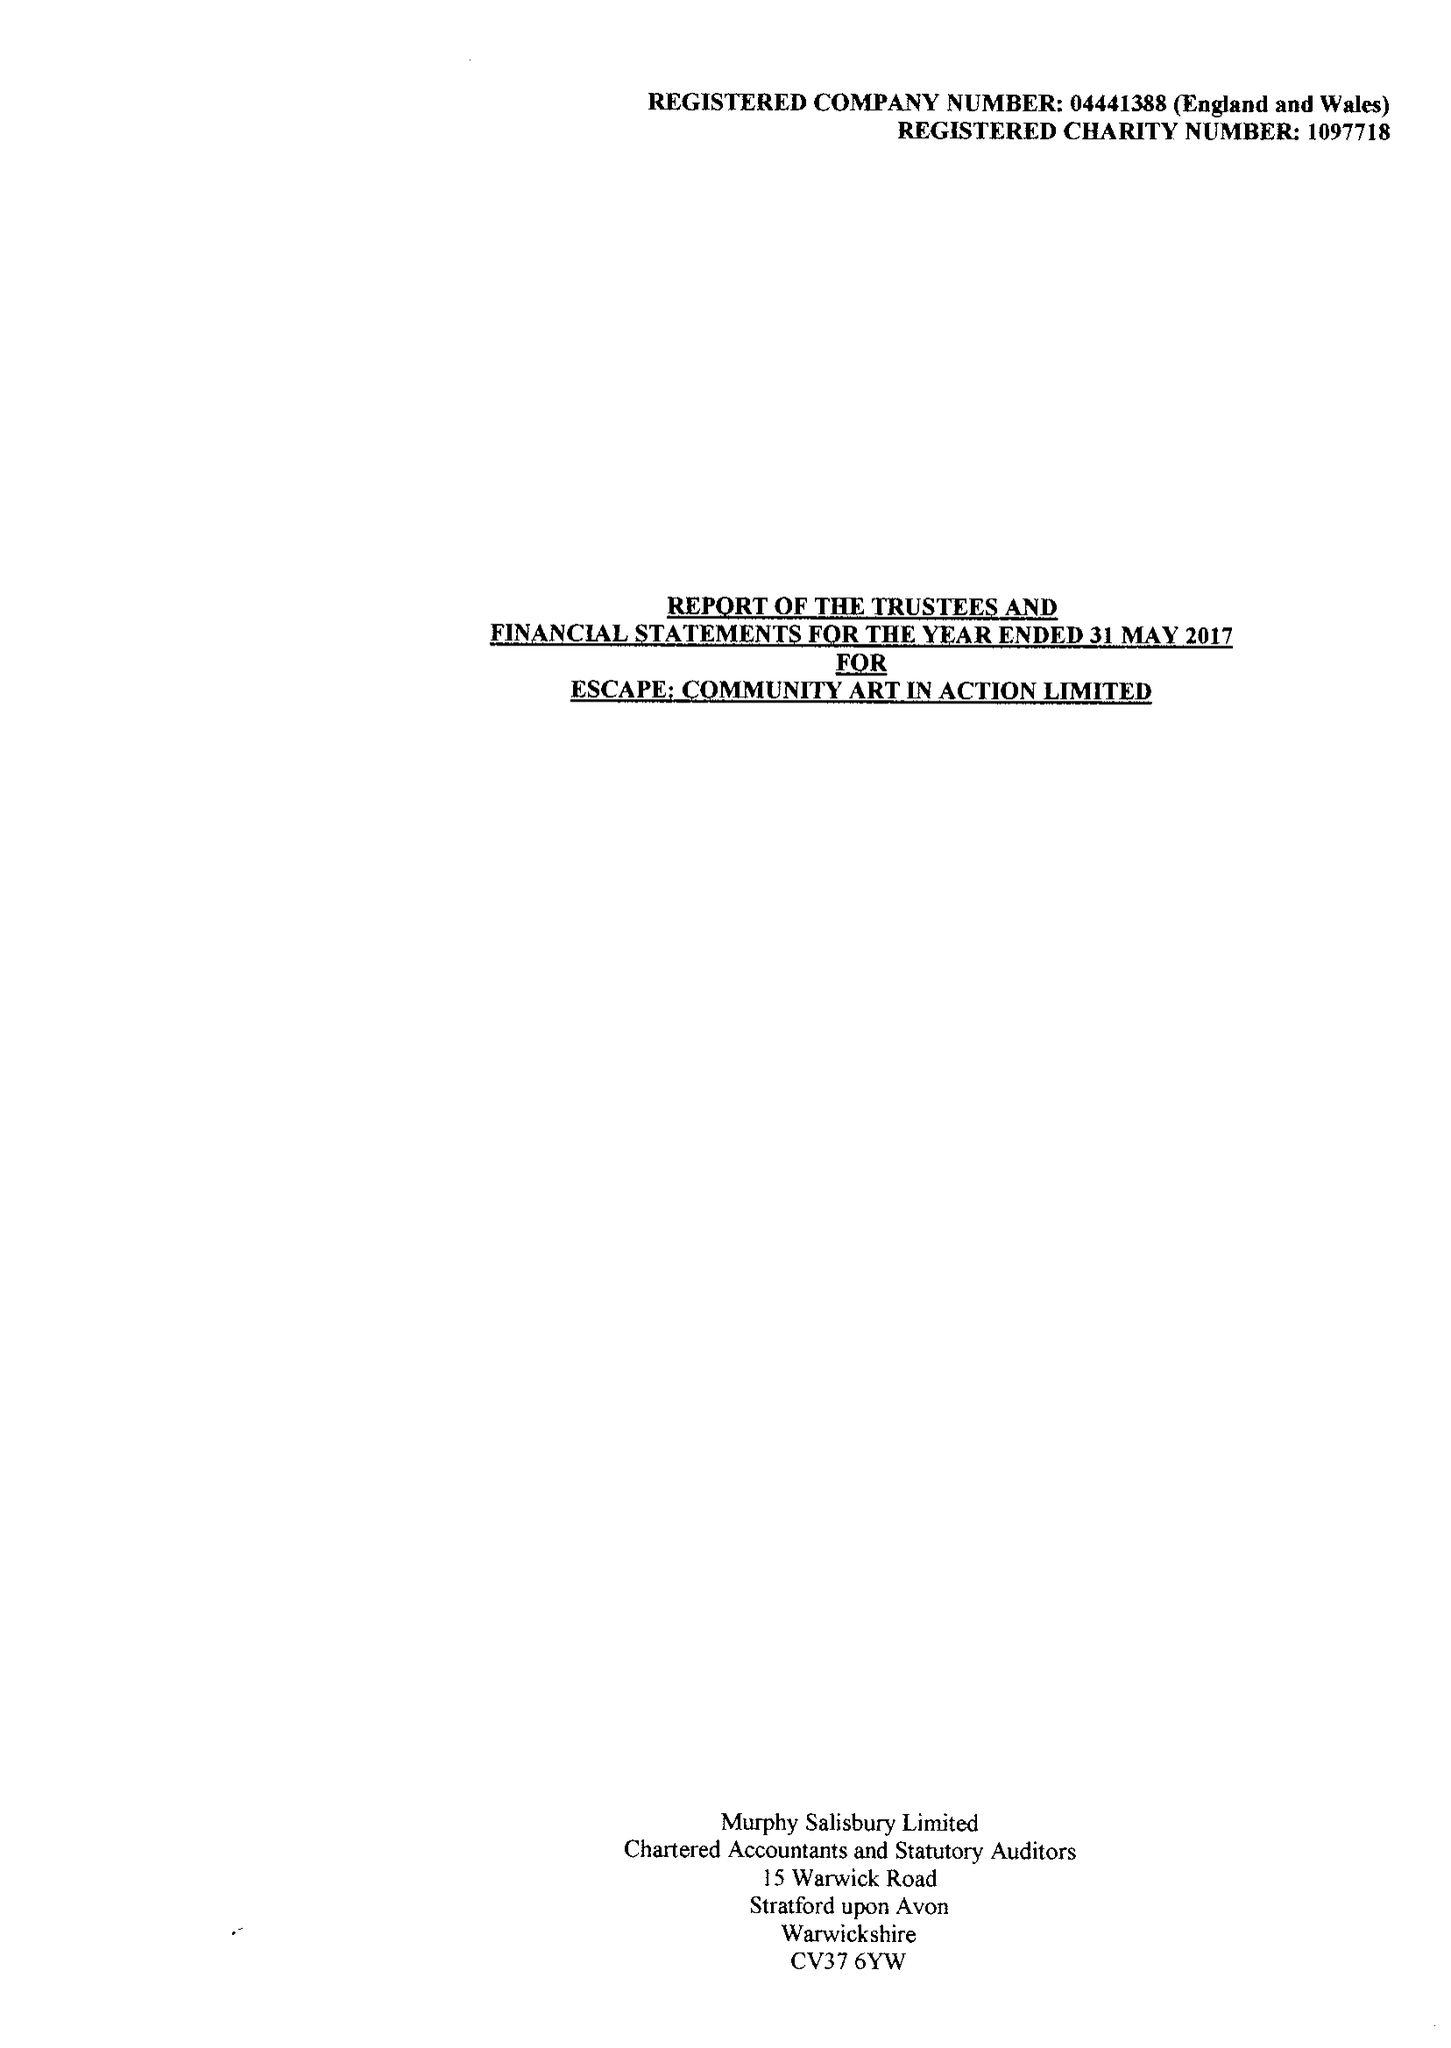What is the value for the income_annually_in_british_pounds?
Answer the question using a single word or phrase. 200630.00 